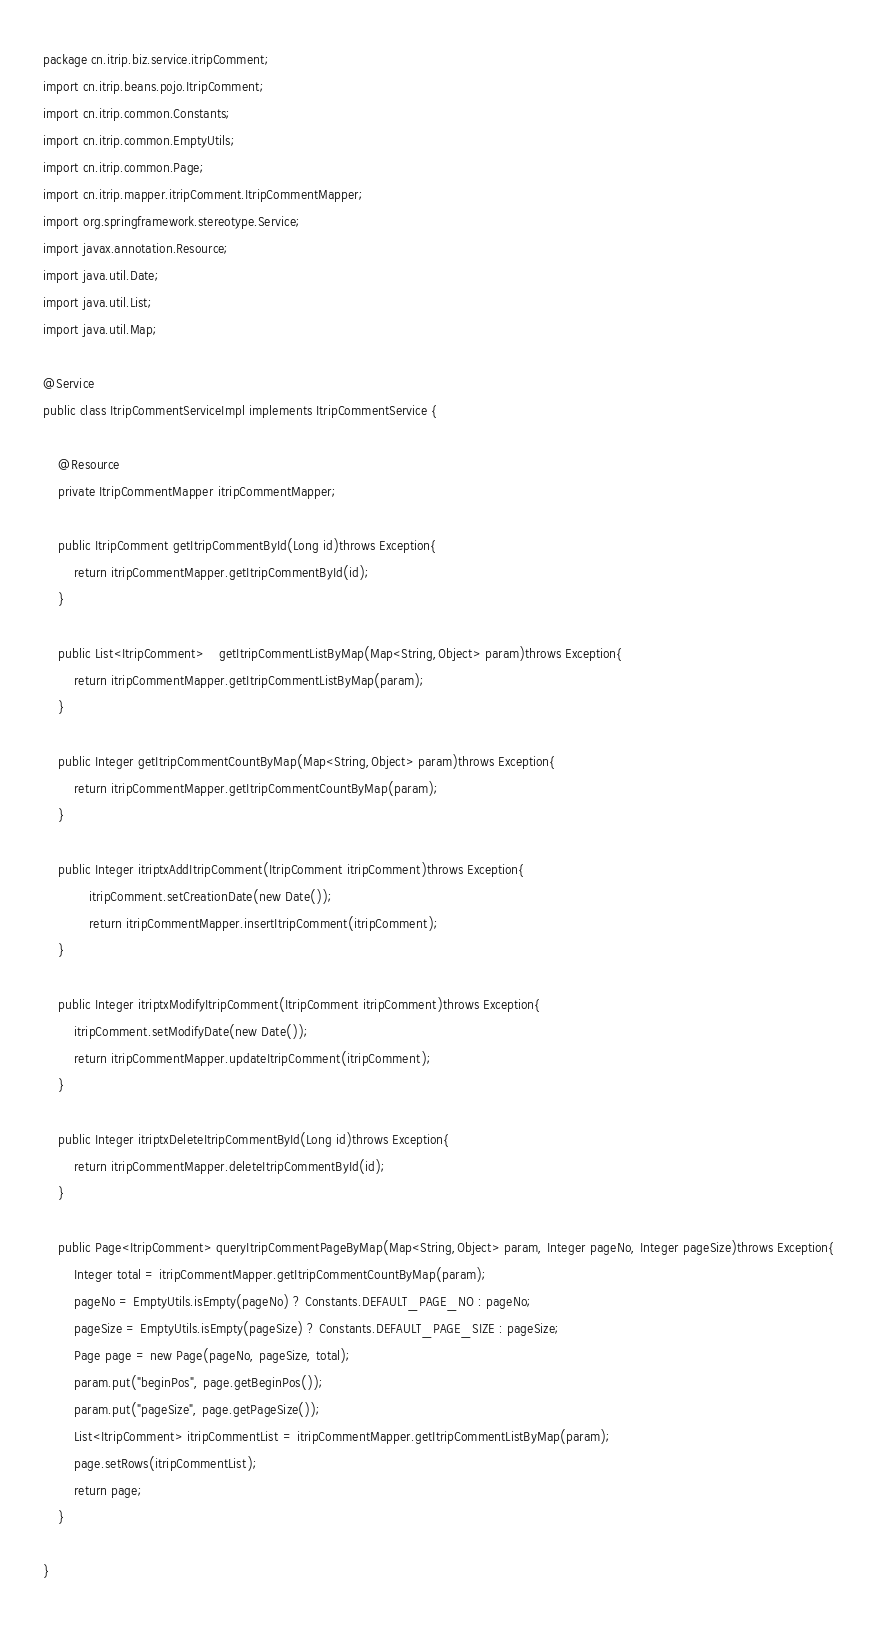Convert code to text. <code><loc_0><loc_0><loc_500><loc_500><_Java_>package cn.itrip.biz.service.itripComment;
import cn.itrip.beans.pojo.ItripComment;
import cn.itrip.common.Constants;
import cn.itrip.common.EmptyUtils;
import cn.itrip.common.Page;
import cn.itrip.mapper.itripComment.ItripCommentMapper;
import org.springframework.stereotype.Service;
import javax.annotation.Resource;
import java.util.Date;
import java.util.List;
import java.util.Map;

@Service
public class ItripCommentServiceImpl implements ItripCommentService {

    @Resource
    private ItripCommentMapper itripCommentMapper;

    public ItripComment getItripCommentById(Long id)throws Exception{
        return itripCommentMapper.getItripCommentById(id);
    }

    public List<ItripComment>	getItripCommentListByMap(Map<String,Object> param)throws Exception{
        return itripCommentMapper.getItripCommentListByMap(param);
    }

    public Integer getItripCommentCountByMap(Map<String,Object> param)throws Exception{
        return itripCommentMapper.getItripCommentCountByMap(param);
    }

    public Integer itriptxAddItripComment(ItripComment itripComment)throws Exception{
            itripComment.setCreationDate(new Date());
            return itripCommentMapper.insertItripComment(itripComment);
    }

    public Integer itriptxModifyItripComment(ItripComment itripComment)throws Exception{
        itripComment.setModifyDate(new Date());
        return itripCommentMapper.updateItripComment(itripComment);
    }

    public Integer itriptxDeleteItripCommentById(Long id)throws Exception{
        return itripCommentMapper.deleteItripCommentById(id);
    }

    public Page<ItripComment> queryItripCommentPageByMap(Map<String,Object> param, Integer pageNo, Integer pageSize)throws Exception{
        Integer total = itripCommentMapper.getItripCommentCountByMap(param);
        pageNo = EmptyUtils.isEmpty(pageNo) ? Constants.DEFAULT_PAGE_NO : pageNo;
        pageSize = EmptyUtils.isEmpty(pageSize) ? Constants.DEFAULT_PAGE_SIZE : pageSize;
        Page page = new Page(pageNo, pageSize, total);
        param.put("beginPos", page.getBeginPos());
        param.put("pageSize", page.getPageSize());
        List<ItripComment> itripCommentList = itripCommentMapper.getItripCommentListByMap(param);
        page.setRows(itripCommentList);
        return page;
    }

}
</code> 